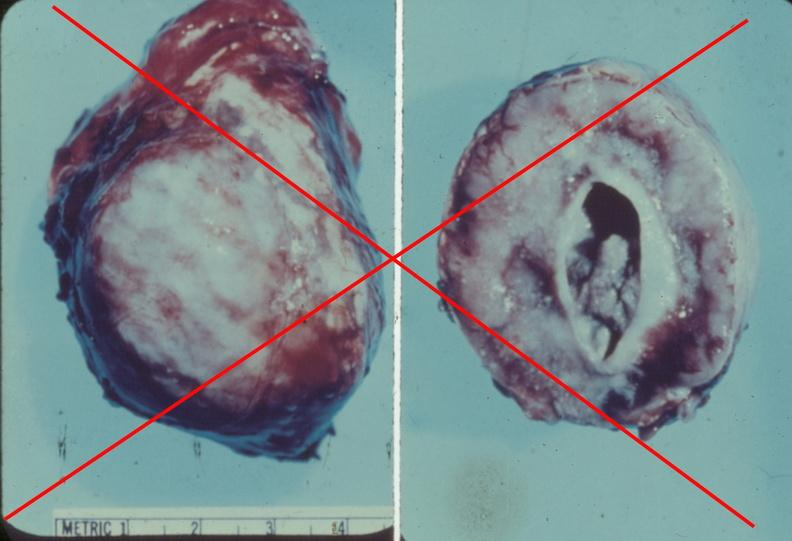does side show adrenal phaeochromocytoma?
Answer the question using a single word or phrase. No 